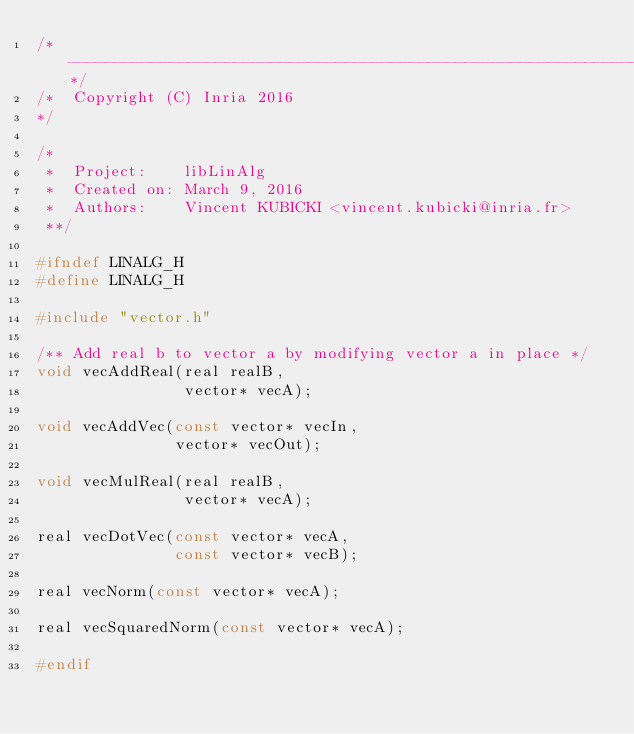<code> <loc_0><loc_0><loc_500><loc_500><_C_>/*--------------------------------------------------------------------*/
/*  Copyright (C) Inria 2016
*/

/*
 *  Project:    libLinAlg
 *  Created on: March 9, 2016
 *  Authors:    Vincent KUBICKI <vincent.kubicki@inria.fr>
 **/

#ifndef LINALG_H
#define LINALG_H

#include "vector.h"

/** Add real b to vector a by modifying vector a in place */
void vecAddReal(real realB,
                vector* vecA);

void vecAddVec(const vector* vecIn,
               vector* vecOut);

void vecMulReal(real realB,
                vector* vecA);

real vecDotVec(const vector* vecA,
               const vector* vecB);

real vecNorm(const vector* vecA);

real vecSquaredNorm(const vector* vecA);

#endif
</code> 